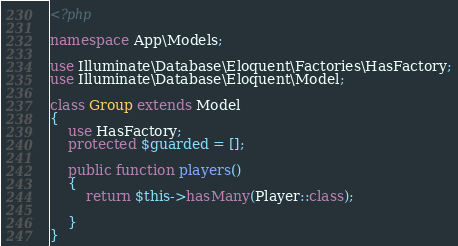<code> <loc_0><loc_0><loc_500><loc_500><_PHP_><?php

namespace App\Models;

use Illuminate\Database\Eloquent\Factories\HasFactory;
use Illuminate\Database\Eloquent\Model;

class Group extends Model
{
    use HasFactory;
    protected $guarded = [];

    public function players()
    {
        return $this->hasMany(Player::class);

    }
}


</code> 